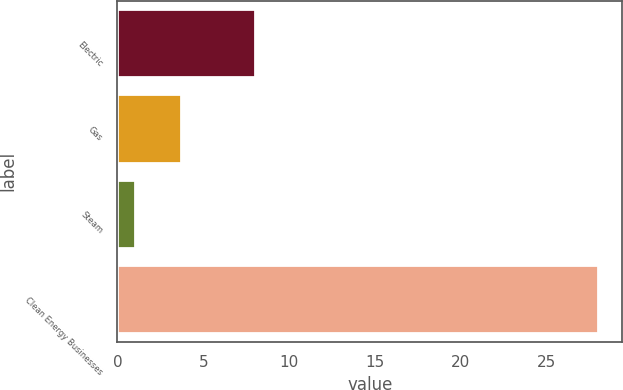Convert chart. <chart><loc_0><loc_0><loc_500><loc_500><bar_chart><fcel>Electric<fcel>Gas<fcel>Steam<fcel>Clean Energy Businesses<nl><fcel>8<fcel>3.7<fcel>1<fcel>28<nl></chart> 